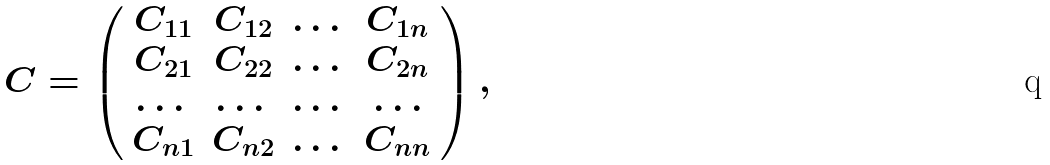Convert formula to latex. <formula><loc_0><loc_0><loc_500><loc_500>C = \left ( \begin{array} { c c c c } C _ { 1 1 } & C _ { 1 2 } & \dots & C _ { 1 n } \\ C _ { 2 1 } & C _ { 2 2 } & \dots & C _ { 2 n } \\ \dots & \dots & \dots & \dots \\ C _ { n 1 } & C _ { n 2 } & \dots & C _ { n n } \end{array} \right ) ,</formula> 